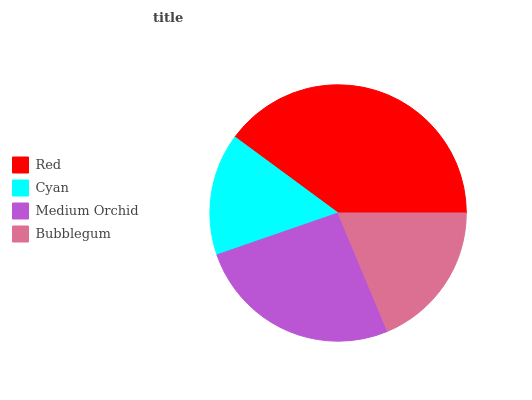Is Cyan the minimum?
Answer yes or no. Yes. Is Red the maximum?
Answer yes or no. Yes. Is Medium Orchid the minimum?
Answer yes or no. No. Is Medium Orchid the maximum?
Answer yes or no. No. Is Medium Orchid greater than Cyan?
Answer yes or no. Yes. Is Cyan less than Medium Orchid?
Answer yes or no. Yes. Is Cyan greater than Medium Orchid?
Answer yes or no. No. Is Medium Orchid less than Cyan?
Answer yes or no. No. Is Medium Orchid the high median?
Answer yes or no. Yes. Is Bubblegum the low median?
Answer yes or no. Yes. Is Red the high median?
Answer yes or no. No. Is Medium Orchid the low median?
Answer yes or no. No. 